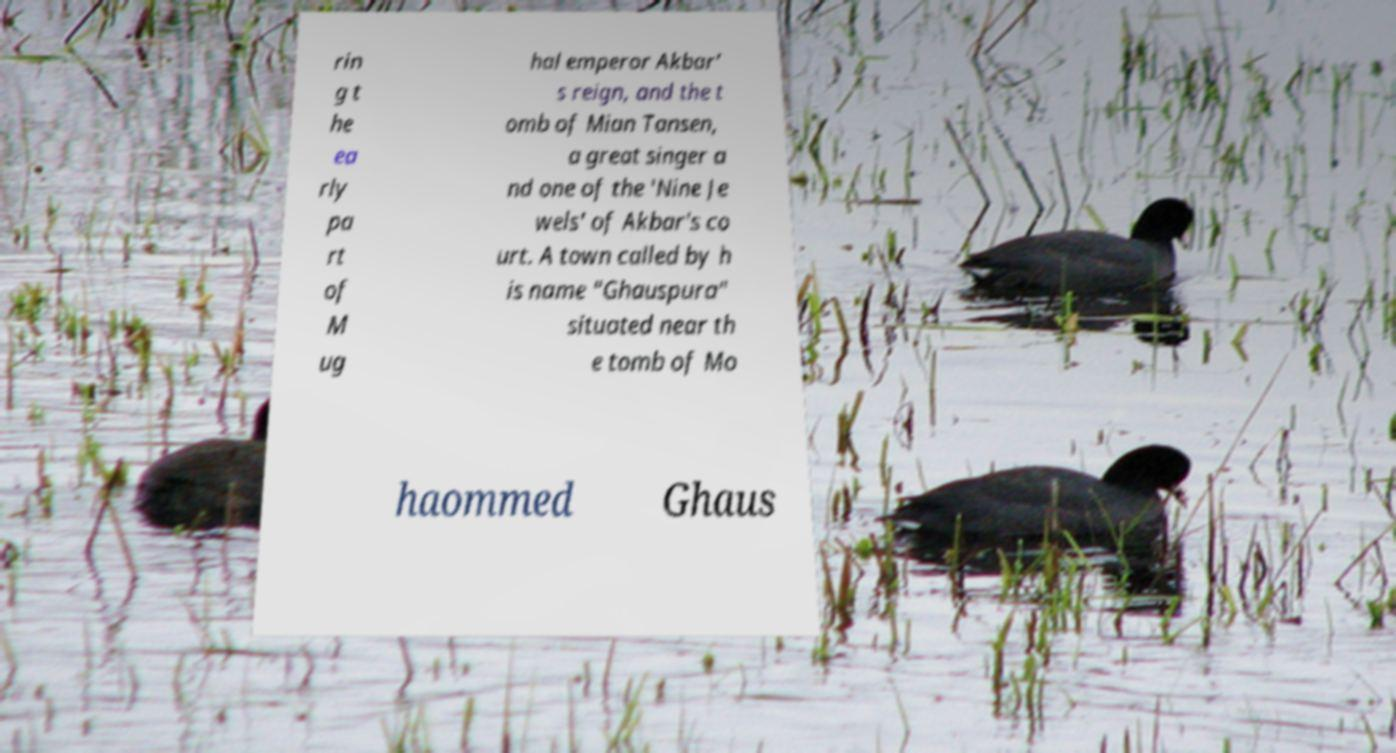What messages or text are displayed in this image? I need them in a readable, typed format. rin g t he ea rly pa rt of M ug hal emperor Akbar’ s reign, and the t omb of Mian Tansen, a great singer a nd one of the 'Nine Je wels' of Akbar's co urt. A town called by h is name "Ghauspura" situated near th e tomb of Mo haommed Ghaus 